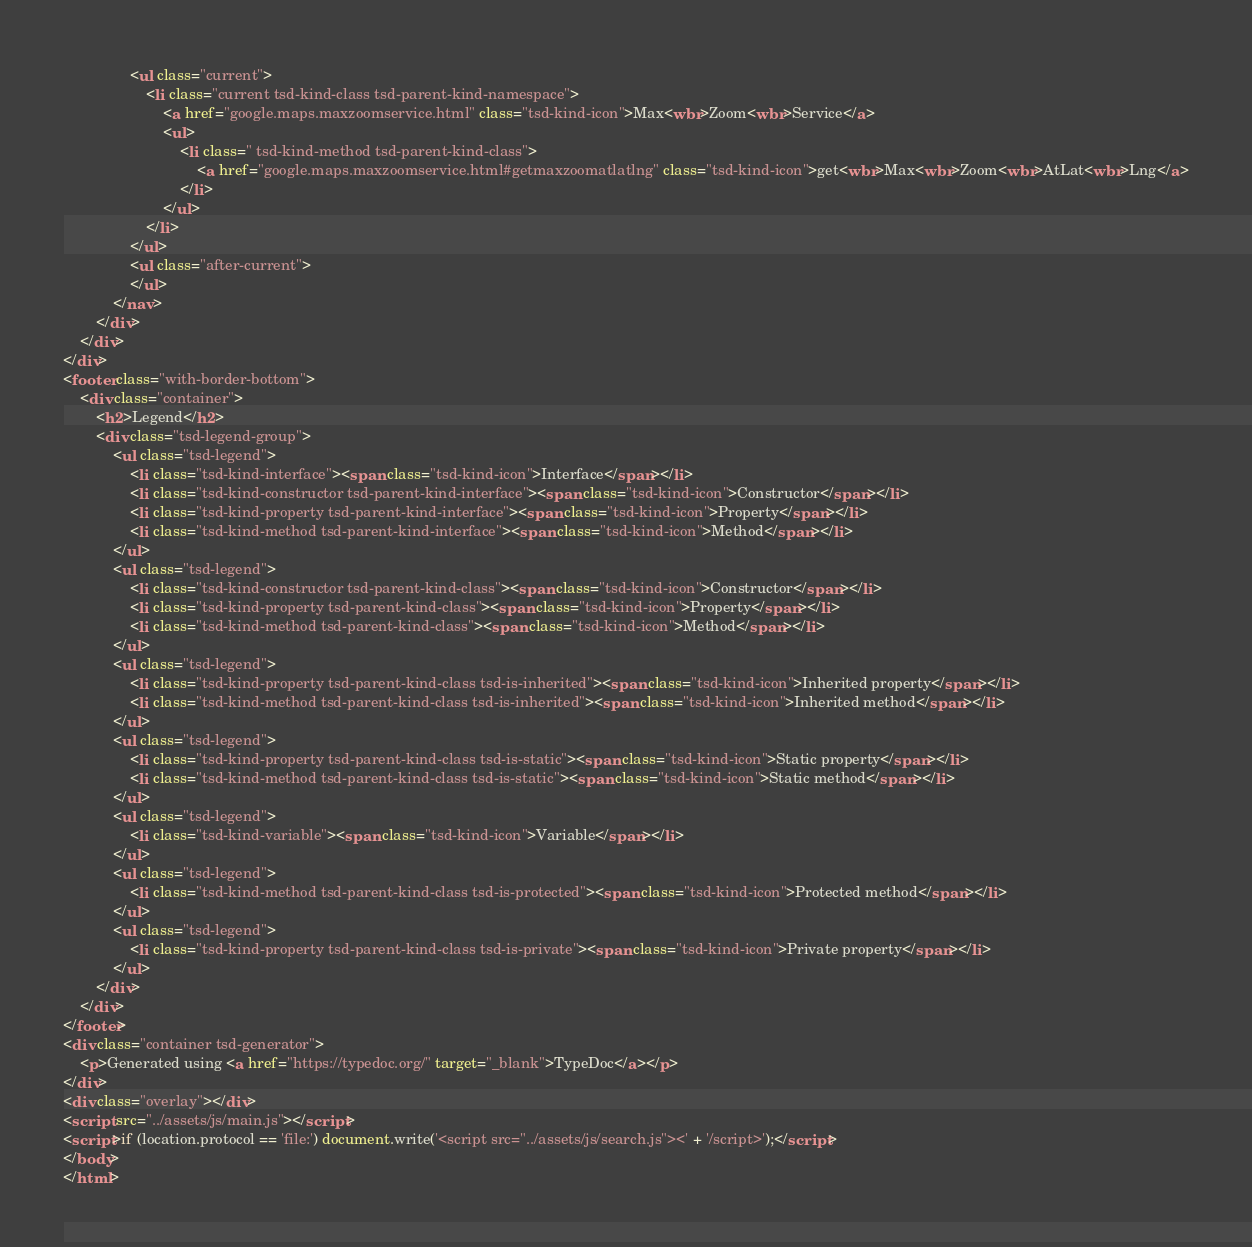<code> <loc_0><loc_0><loc_500><loc_500><_HTML_>				<ul class="current">
					<li class="current tsd-kind-class tsd-parent-kind-namespace">
						<a href="google.maps.maxzoomservice.html" class="tsd-kind-icon">Max<wbr>Zoom<wbr>Service</a>
						<ul>
							<li class=" tsd-kind-method tsd-parent-kind-class">
								<a href="google.maps.maxzoomservice.html#getmaxzoomatlatlng" class="tsd-kind-icon">get<wbr>Max<wbr>Zoom<wbr>AtLat<wbr>Lng</a>
							</li>
						</ul>
					</li>
				</ul>
				<ul class="after-current">
				</ul>
			</nav>
		</div>
	</div>
</div>
<footer class="with-border-bottom">
	<div class="container">
		<h2>Legend</h2>
		<div class="tsd-legend-group">
			<ul class="tsd-legend">
				<li class="tsd-kind-interface"><span class="tsd-kind-icon">Interface</span></li>
				<li class="tsd-kind-constructor tsd-parent-kind-interface"><span class="tsd-kind-icon">Constructor</span></li>
				<li class="tsd-kind-property tsd-parent-kind-interface"><span class="tsd-kind-icon">Property</span></li>
				<li class="tsd-kind-method tsd-parent-kind-interface"><span class="tsd-kind-icon">Method</span></li>
			</ul>
			<ul class="tsd-legend">
				<li class="tsd-kind-constructor tsd-parent-kind-class"><span class="tsd-kind-icon">Constructor</span></li>
				<li class="tsd-kind-property tsd-parent-kind-class"><span class="tsd-kind-icon">Property</span></li>
				<li class="tsd-kind-method tsd-parent-kind-class"><span class="tsd-kind-icon">Method</span></li>
			</ul>
			<ul class="tsd-legend">
				<li class="tsd-kind-property tsd-parent-kind-class tsd-is-inherited"><span class="tsd-kind-icon">Inherited property</span></li>
				<li class="tsd-kind-method tsd-parent-kind-class tsd-is-inherited"><span class="tsd-kind-icon">Inherited method</span></li>
			</ul>
			<ul class="tsd-legend">
				<li class="tsd-kind-property tsd-parent-kind-class tsd-is-static"><span class="tsd-kind-icon">Static property</span></li>
				<li class="tsd-kind-method tsd-parent-kind-class tsd-is-static"><span class="tsd-kind-icon">Static method</span></li>
			</ul>
			<ul class="tsd-legend">
				<li class="tsd-kind-variable"><span class="tsd-kind-icon">Variable</span></li>
			</ul>
			<ul class="tsd-legend">
				<li class="tsd-kind-method tsd-parent-kind-class tsd-is-protected"><span class="tsd-kind-icon">Protected method</span></li>
			</ul>
			<ul class="tsd-legend">
				<li class="tsd-kind-property tsd-parent-kind-class tsd-is-private"><span class="tsd-kind-icon">Private property</span></li>
			</ul>
		</div>
	</div>
</footer>
<div class="container tsd-generator">
	<p>Generated using <a href="https://typedoc.org/" target="_blank">TypeDoc</a></p>
</div>
<div class="overlay"></div>
<script src="../assets/js/main.js"></script>
<script>if (location.protocol == 'file:') document.write('<script src="../assets/js/search.js"><' + '/script>');</script>
</body>
</html></code> 